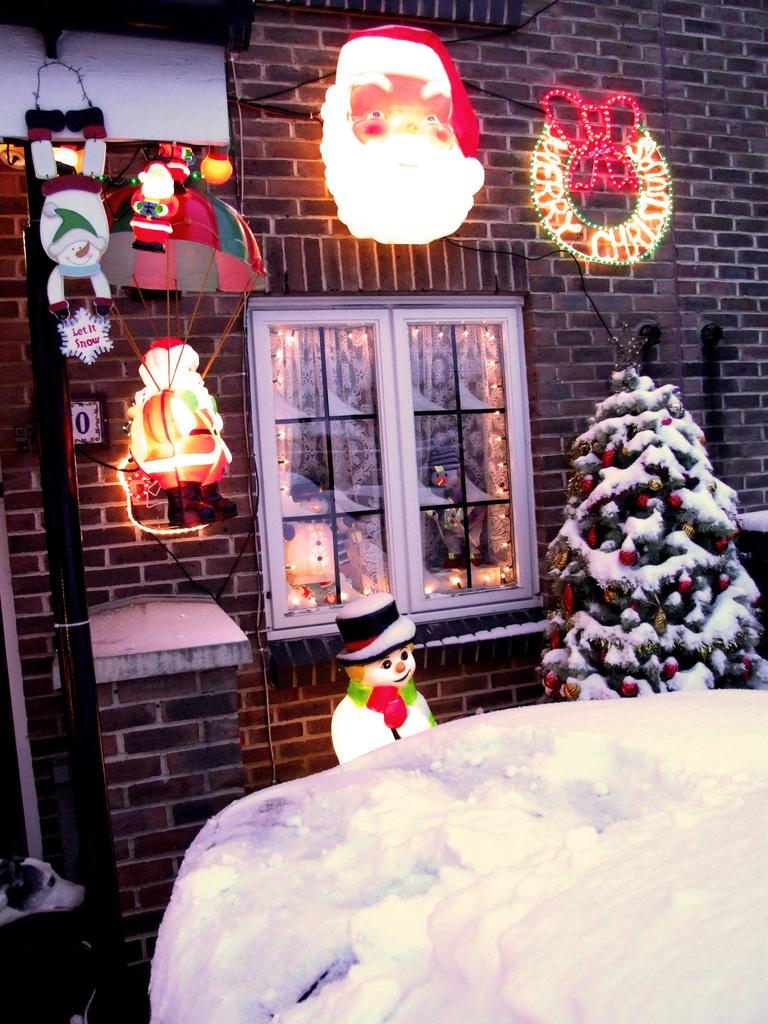What type of structure is visible in the image? There is a building with a window in the image. What object can be seen near the building? There is a pole in the image. What can be found on the wall of the building? There are decorations on a wall in the image. What is an object used for protection from the rain in the image? There is an umbrella in the image. What type of figurines are present in the image? There are dolls in the image. What type of illumination is present in the image? There are lights in the image. What weather condition is depicted in the image? There is snow in the image. What is a unique feature of the tree in the image? There is a tree decorated with balls and dolls in the image. How many times does the mom fold her leg in the image? There is no mention of a mom or folding legs in the image. What type of animal is using the umbrella in the image? There is no animal present in the image; it is an umbrella for humans. 